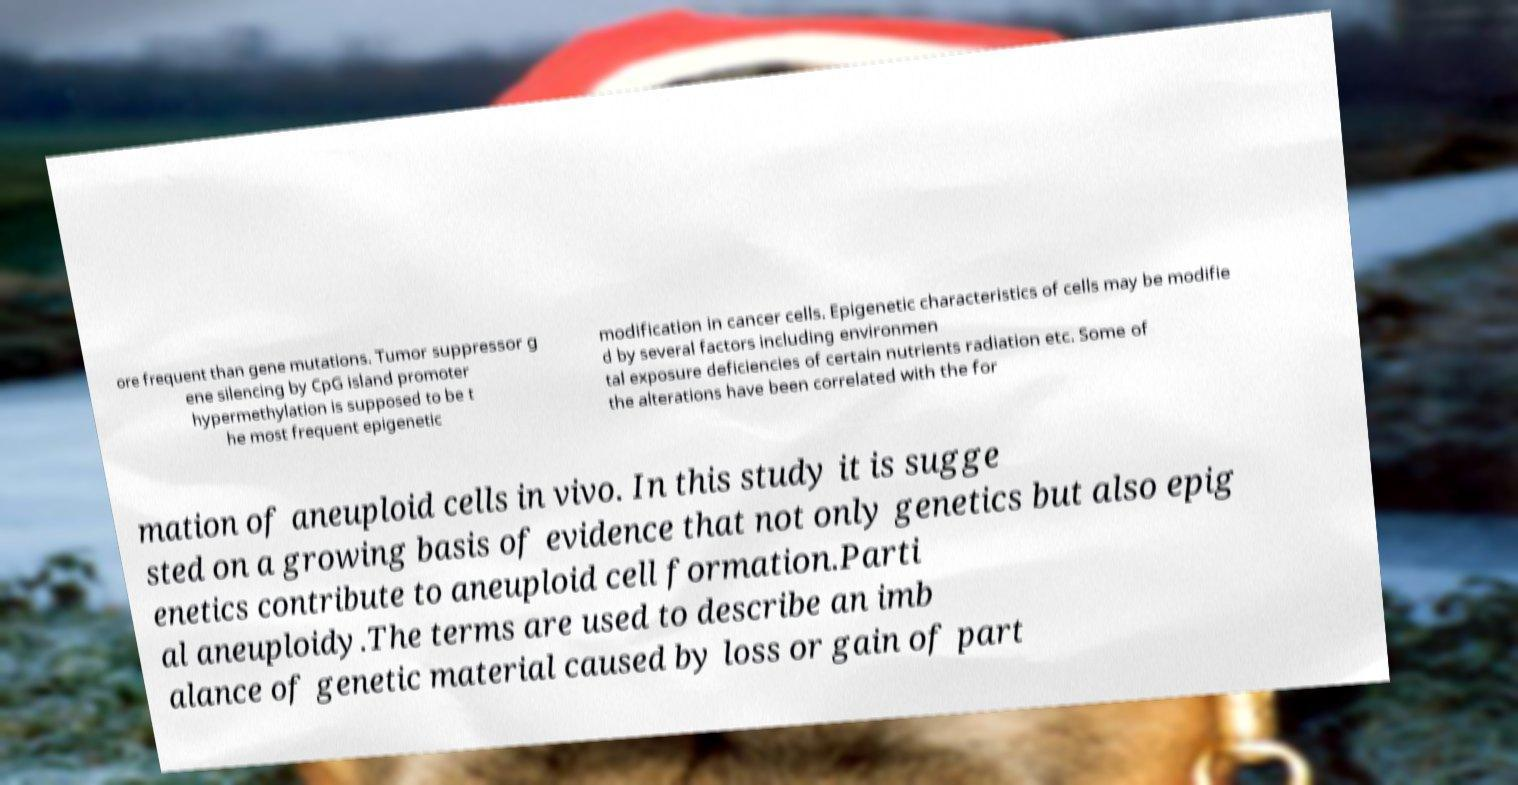There's text embedded in this image that I need extracted. Can you transcribe it verbatim? ore frequent than gene mutations. Tumor suppressor g ene silencing by CpG island promoter hypermethylation is supposed to be t he most frequent epigenetic modification in cancer cells. Epigenetic characteristics of cells may be modifie d by several factors including environmen tal exposure deficiencies of certain nutrients radiation etc. Some of the alterations have been correlated with the for mation of aneuploid cells in vivo. In this study it is sugge sted on a growing basis of evidence that not only genetics but also epig enetics contribute to aneuploid cell formation.Parti al aneuploidy.The terms are used to describe an imb alance of genetic material caused by loss or gain of part 